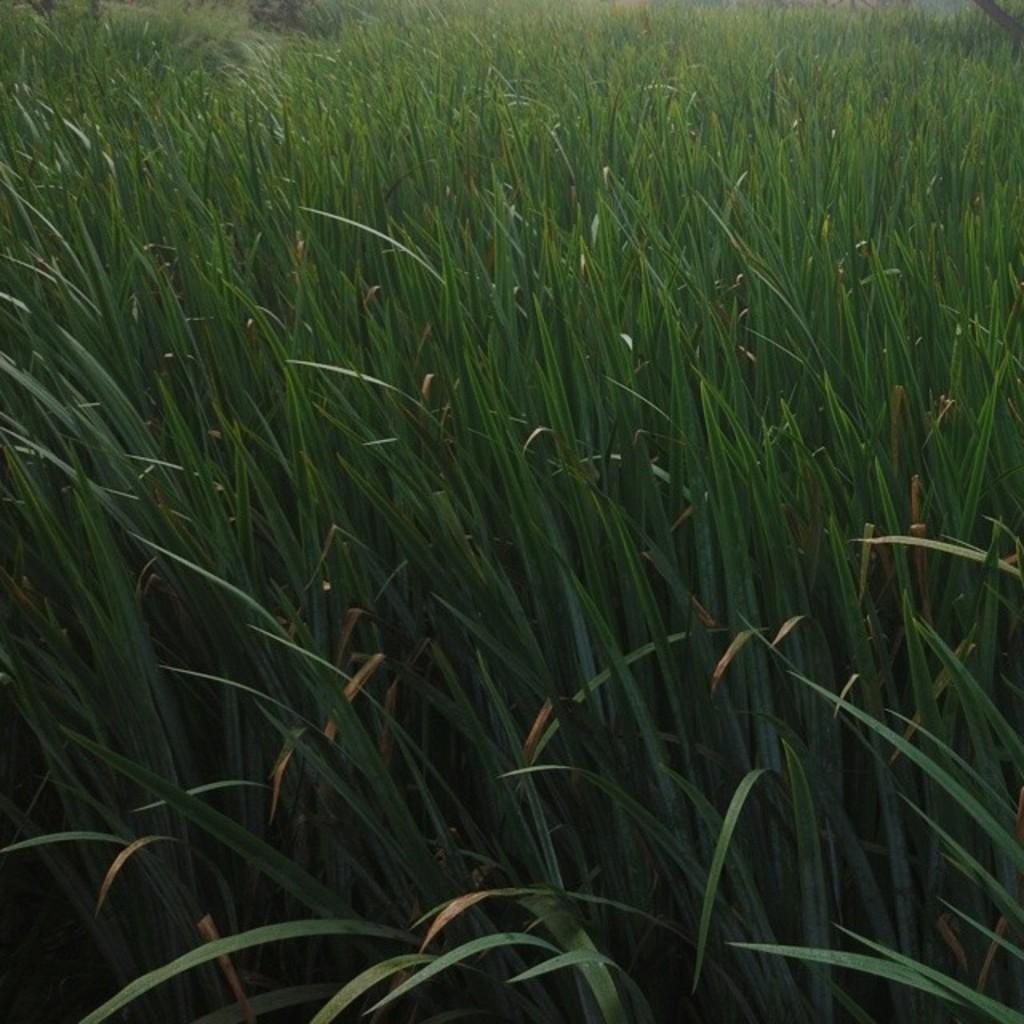What type of plants can be seen in the image? There are green color plants in the image. How many goldfish are attending the feast in the image? There are no goldfish or feast present in the image; it only features green color plants. 